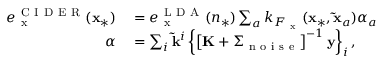<formula> <loc_0><loc_0><loc_500><loc_500>\begin{array} { r l } { e _ { x } ^ { C I D E R } ( x _ { * } ) } & = e _ { x } ^ { L D A } ( n _ { * } ) \sum _ { a } k _ { F _ { x } } ( x _ { * } , \tilde { x } _ { a } ) \alpha _ { a } } \\ { \alpha } & = \sum _ { i } \tilde { k } ^ { i } \left \{ \left [ K + \Sigma _ { n o i s e } \right ] ^ { - 1 } y \right \} _ { i } , } \end{array}</formula> 